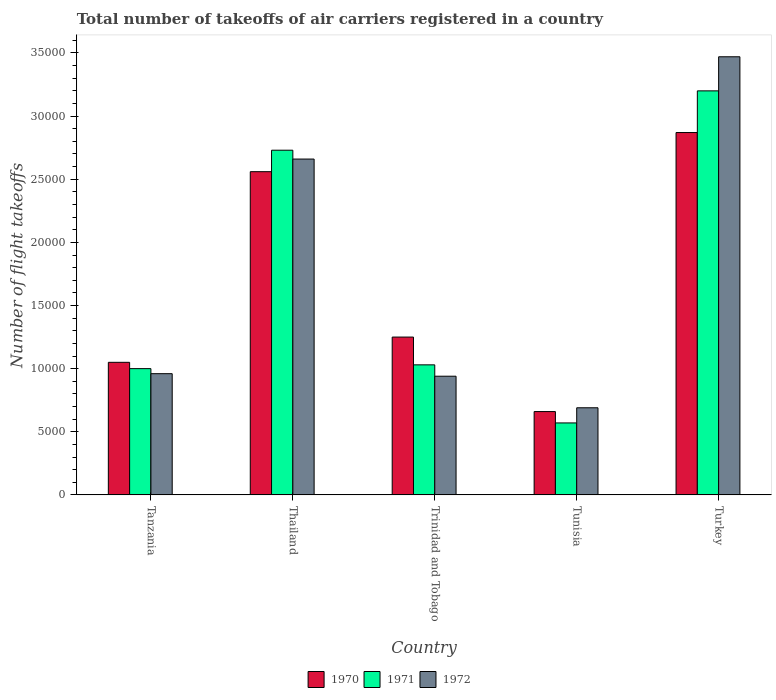How many different coloured bars are there?
Your answer should be very brief. 3. How many groups of bars are there?
Offer a terse response. 5. Are the number of bars per tick equal to the number of legend labels?
Your answer should be compact. Yes. Are the number of bars on each tick of the X-axis equal?
Provide a succinct answer. Yes. How many bars are there on the 2nd tick from the left?
Ensure brevity in your answer.  3. How many bars are there on the 2nd tick from the right?
Offer a very short reply. 3. What is the label of the 5th group of bars from the left?
Give a very brief answer. Turkey. In how many cases, is the number of bars for a given country not equal to the number of legend labels?
Your answer should be compact. 0. What is the total number of flight takeoffs in 1970 in Tunisia?
Give a very brief answer. 6600. Across all countries, what is the maximum total number of flight takeoffs in 1972?
Provide a succinct answer. 3.47e+04. Across all countries, what is the minimum total number of flight takeoffs in 1971?
Offer a terse response. 5700. In which country was the total number of flight takeoffs in 1970 minimum?
Offer a terse response. Tunisia. What is the total total number of flight takeoffs in 1972 in the graph?
Your answer should be very brief. 8.72e+04. What is the difference between the total number of flight takeoffs in 1970 in Trinidad and Tobago and that in Tunisia?
Provide a succinct answer. 5900. What is the difference between the total number of flight takeoffs in 1972 in Tanzania and the total number of flight takeoffs in 1970 in Tunisia?
Your answer should be very brief. 3000. What is the average total number of flight takeoffs in 1972 per country?
Offer a terse response. 1.74e+04. What is the difference between the total number of flight takeoffs of/in 1972 and total number of flight takeoffs of/in 1970 in Trinidad and Tobago?
Your response must be concise. -3100. What is the ratio of the total number of flight takeoffs in 1972 in Thailand to that in Turkey?
Provide a succinct answer. 0.77. What is the difference between the highest and the second highest total number of flight takeoffs in 1971?
Provide a succinct answer. 4700. What is the difference between the highest and the lowest total number of flight takeoffs in 1971?
Ensure brevity in your answer.  2.63e+04. What does the 3rd bar from the right in Turkey represents?
Make the answer very short. 1970. Is it the case that in every country, the sum of the total number of flight takeoffs in 1971 and total number of flight takeoffs in 1972 is greater than the total number of flight takeoffs in 1970?
Your response must be concise. Yes. Are all the bars in the graph horizontal?
Ensure brevity in your answer.  No. What is the difference between two consecutive major ticks on the Y-axis?
Offer a terse response. 5000. Where does the legend appear in the graph?
Give a very brief answer. Bottom center. What is the title of the graph?
Keep it short and to the point. Total number of takeoffs of air carriers registered in a country. What is the label or title of the X-axis?
Give a very brief answer. Country. What is the label or title of the Y-axis?
Ensure brevity in your answer.  Number of flight takeoffs. What is the Number of flight takeoffs in 1970 in Tanzania?
Your response must be concise. 1.05e+04. What is the Number of flight takeoffs in 1971 in Tanzania?
Ensure brevity in your answer.  10000. What is the Number of flight takeoffs in 1972 in Tanzania?
Make the answer very short. 9600. What is the Number of flight takeoffs of 1970 in Thailand?
Offer a very short reply. 2.56e+04. What is the Number of flight takeoffs in 1971 in Thailand?
Your response must be concise. 2.73e+04. What is the Number of flight takeoffs in 1972 in Thailand?
Ensure brevity in your answer.  2.66e+04. What is the Number of flight takeoffs in 1970 in Trinidad and Tobago?
Provide a short and direct response. 1.25e+04. What is the Number of flight takeoffs of 1971 in Trinidad and Tobago?
Provide a short and direct response. 1.03e+04. What is the Number of flight takeoffs in 1972 in Trinidad and Tobago?
Provide a succinct answer. 9400. What is the Number of flight takeoffs in 1970 in Tunisia?
Provide a succinct answer. 6600. What is the Number of flight takeoffs in 1971 in Tunisia?
Give a very brief answer. 5700. What is the Number of flight takeoffs in 1972 in Tunisia?
Offer a terse response. 6900. What is the Number of flight takeoffs in 1970 in Turkey?
Provide a succinct answer. 2.87e+04. What is the Number of flight takeoffs of 1971 in Turkey?
Provide a short and direct response. 3.20e+04. What is the Number of flight takeoffs of 1972 in Turkey?
Offer a terse response. 3.47e+04. Across all countries, what is the maximum Number of flight takeoffs in 1970?
Keep it short and to the point. 2.87e+04. Across all countries, what is the maximum Number of flight takeoffs of 1971?
Keep it short and to the point. 3.20e+04. Across all countries, what is the maximum Number of flight takeoffs in 1972?
Make the answer very short. 3.47e+04. Across all countries, what is the minimum Number of flight takeoffs of 1970?
Keep it short and to the point. 6600. Across all countries, what is the minimum Number of flight takeoffs of 1971?
Your answer should be compact. 5700. Across all countries, what is the minimum Number of flight takeoffs of 1972?
Your response must be concise. 6900. What is the total Number of flight takeoffs in 1970 in the graph?
Give a very brief answer. 8.39e+04. What is the total Number of flight takeoffs in 1971 in the graph?
Offer a terse response. 8.53e+04. What is the total Number of flight takeoffs in 1972 in the graph?
Provide a short and direct response. 8.72e+04. What is the difference between the Number of flight takeoffs in 1970 in Tanzania and that in Thailand?
Make the answer very short. -1.51e+04. What is the difference between the Number of flight takeoffs in 1971 in Tanzania and that in Thailand?
Ensure brevity in your answer.  -1.73e+04. What is the difference between the Number of flight takeoffs of 1972 in Tanzania and that in Thailand?
Provide a succinct answer. -1.70e+04. What is the difference between the Number of flight takeoffs in 1970 in Tanzania and that in Trinidad and Tobago?
Offer a terse response. -2000. What is the difference between the Number of flight takeoffs of 1971 in Tanzania and that in Trinidad and Tobago?
Your response must be concise. -300. What is the difference between the Number of flight takeoffs in 1970 in Tanzania and that in Tunisia?
Your answer should be very brief. 3900. What is the difference between the Number of flight takeoffs in 1971 in Tanzania and that in Tunisia?
Offer a very short reply. 4300. What is the difference between the Number of flight takeoffs in 1972 in Tanzania and that in Tunisia?
Provide a succinct answer. 2700. What is the difference between the Number of flight takeoffs in 1970 in Tanzania and that in Turkey?
Give a very brief answer. -1.82e+04. What is the difference between the Number of flight takeoffs in 1971 in Tanzania and that in Turkey?
Provide a short and direct response. -2.20e+04. What is the difference between the Number of flight takeoffs in 1972 in Tanzania and that in Turkey?
Make the answer very short. -2.51e+04. What is the difference between the Number of flight takeoffs of 1970 in Thailand and that in Trinidad and Tobago?
Your response must be concise. 1.31e+04. What is the difference between the Number of flight takeoffs in 1971 in Thailand and that in Trinidad and Tobago?
Offer a very short reply. 1.70e+04. What is the difference between the Number of flight takeoffs of 1972 in Thailand and that in Trinidad and Tobago?
Provide a succinct answer. 1.72e+04. What is the difference between the Number of flight takeoffs in 1970 in Thailand and that in Tunisia?
Ensure brevity in your answer.  1.90e+04. What is the difference between the Number of flight takeoffs of 1971 in Thailand and that in Tunisia?
Offer a terse response. 2.16e+04. What is the difference between the Number of flight takeoffs of 1972 in Thailand and that in Tunisia?
Provide a succinct answer. 1.97e+04. What is the difference between the Number of flight takeoffs of 1970 in Thailand and that in Turkey?
Provide a short and direct response. -3100. What is the difference between the Number of flight takeoffs in 1971 in Thailand and that in Turkey?
Provide a succinct answer. -4700. What is the difference between the Number of flight takeoffs of 1972 in Thailand and that in Turkey?
Offer a terse response. -8100. What is the difference between the Number of flight takeoffs in 1970 in Trinidad and Tobago and that in Tunisia?
Offer a very short reply. 5900. What is the difference between the Number of flight takeoffs in 1971 in Trinidad and Tobago and that in Tunisia?
Provide a short and direct response. 4600. What is the difference between the Number of flight takeoffs in 1972 in Trinidad and Tobago and that in Tunisia?
Offer a very short reply. 2500. What is the difference between the Number of flight takeoffs in 1970 in Trinidad and Tobago and that in Turkey?
Offer a very short reply. -1.62e+04. What is the difference between the Number of flight takeoffs in 1971 in Trinidad and Tobago and that in Turkey?
Provide a succinct answer. -2.17e+04. What is the difference between the Number of flight takeoffs of 1972 in Trinidad and Tobago and that in Turkey?
Offer a very short reply. -2.53e+04. What is the difference between the Number of flight takeoffs in 1970 in Tunisia and that in Turkey?
Give a very brief answer. -2.21e+04. What is the difference between the Number of flight takeoffs in 1971 in Tunisia and that in Turkey?
Offer a very short reply. -2.63e+04. What is the difference between the Number of flight takeoffs of 1972 in Tunisia and that in Turkey?
Make the answer very short. -2.78e+04. What is the difference between the Number of flight takeoffs of 1970 in Tanzania and the Number of flight takeoffs of 1971 in Thailand?
Give a very brief answer. -1.68e+04. What is the difference between the Number of flight takeoffs of 1970 in Tanzania and the Number of flight takeoffs of 1972 in Thailand?
Ensure brevity in your answer.  -1.61e+04. What is the difference between the Number of flight takeoffs of 1971 in Tanzania and the Number of flight takeoffs of 1972 in Thailand?
Provide a short and direct response. -1.66e+04. What is the difference between the Number of flight takeoffs of 1970 in Tanzania and the Number of flight takeoffs of 1972 in Trinidad and Tobago?
Ensure brevity in your answer.  1100. What is the difference between the Number of flight takeoffs of 1971 in Tanzania and the Number of flight takeoffs of 1972 in Trinidad and Tobago?
Offer a terse response. 600. What is the difference between the Number of flight takeoffs in 1970 in Tanzania and the Number of flight takeoffs in 1971 in Tunisia?
Offer a terse response. 4800. What is the difference between the Number of flight takeoffs in 1970 in Tanzania and the Number of flight takeoffs in 1972 in Tunisia?
Offer a very short reply. 3600. What is the difference between the Number of flight takeoffs of 1971 in Tanzania and the Number of flight takeoffs of 1972 in Tunisia?
Ensure brevity in your answer.  3100. What is the difference between the Number of flight takeoffs of 1970 in Tanzania and the Number of flight takeoffs of 1971 in Turkey?
Keep it short and to the point. -2.15e+04. What is the difference between the Number of flight takeoffs of 1970 in Tanzania and the Number of flight takeoffs of 1972 in Turkey?
Your answer should be compact. -2.42e+04. What is the difference between the Number of flight takeoffs in 1971 in Tanzania and the Number of flight takeoffs in 1972 in Turkey?
Offer a very short reply. -2.47e+04. What is the difference between the Number of flight takeoffs in 1970 in Thailand and the Number of flight takeoffs in 1971 in Trinidad and Tobago?
Make the answer very short. 1.53e+04. What is the difference between the Number of flight takeoffs of 1970 in Thailand and the Number of flight takeoffs of 1972 in Trinidad and Tobago?
Give a very brief answer. 1.62e+04. What is the difference between the Number of flight takeoffs of 1971 in Thailand and the Number of flight takeoffs of 1972 in Trinidad and Tobago?
Make the answer very short. 1.79e+04. What is the difference between the Number of flight takeoffs of 1970 in Thailand and the Number of flight takeoffs of 1971 in Tunisia?
Keep it short and to the point. 1.99e+04. What is the difference between the Number of flight takeoffs of 1970 in Thailand and the Number of flight takeoffs of 1972 in Tunisia?
Your response must be concise. 1.87e+04. What is the difference between the Number of flight takeoffs of 1971 in Thailand and the Number of flight takeoffs of 1972 in Tunisia?
Offer a terse response. 2.04e+04. What is the difference between the Number of flight takeoffs in 1970 in Thailand and the Number of flight takeoffs in 1971 in Turkey?
Provide a short and direct response. -6400. What is the difference between the Number of flight takeoffs in 1970 in Thailand and the Number of flight takeoffs in 1972 in Turkey?
Your response must be concise. -9100. What is the difference between the Number of flight takeoffs in 1971 in Thailand and the Number of flight takeoffs in 1972 in Turkey?
Your answer should be compact. -7400. What is the difference between the Number of flight takeoffs of 1970 in Trinidad and Tobago and the Number of flight takeoffs of 1971 in Tunisia?
Make the answer very short. 6800. What is the difference between the Number of flight takeoffs of 1970 in Trinidad and Tobago and the Number of flight takeoffs of 1972 in Tunisia?
Give a very brief answer. 5600. What is the difference between the Number of flight takeoffs of 1971 in Trinidad and Tobago and the Number of flight takeoffs of 1972 in Tunisia?
Make the answer very short. 3400. What is the difference between the Number of flight takeoffs of 1970 in Trinidad and Tobago and the Number of flight takeoffs of 1971 in Turkey?
Give a very brief answer. -1.95e+04. What is the difference between the Number of flight takeoffs in 1970 in Trinidad and Tobago and the Number of flight takeoffs in 1972 in Turkey?
Your response must be concise. -2.22e+04. What is the difference between the Number of flight takeoffs in 1971 in Trinidad and Tobago and the Number of flight takeoffs in 1972 in Turkey?
Your response must be concise. -2.44e+04. What is the difference between the Number of flight takeoffs of 1970 in Tunisia and the Number of flight takeoffs of 1971 in Turkey?
Ensure brevity in your answer.  -2.54e+04. What is the difference between the Number of flight takeoffs in 1970 in Tunisia and the Number of flight takeoffs in 1972 in Turkey?
Ensure brevity in your answer.  -2.81e+04. What is the difference between the Number of flight takeoffs in 1971 in Tunisia and the Number of flight takeoffs in 1972 in Turkey?
Your response must be concise. -2.90e+04. What is the average Number of flight takeoffs of 1970 per country?
Offer a terse response. 1.68e+04. What is the average Number of flight takeoffs of 1971 per country?
Make the answer very short. 1.71e+04. What is the average Number of flight takeoffs in 1972 per country?
Your answer should be compact. 1.74e+04. What is the difference between the Number of flight takeoffs of 1970 and Number of flight takeoffs of 1972 in Tanzania?
Offer a very short reply. 900. What is the difference between the Number of flight takeoffs of 1970 and Number of flight takeoffs of 1971 in Thailand?
Provide a short and direct response. -1700. What is the difference between the Number of flight takeoffs of 1970 and Number of flight takeoffs of 1972 in Thailand?
Your answer should be compact. -1000. What is the difference between the Number of flight takeoffs in 1971 and Number of flight takeoffs in 1972 in Thailand?
Keep it short and to the point. 700. What is the difference between the Number of flight takeoffs in 1970 and Number of flight takeoffs in 1971 in Trinidad and Tobago?
Your answer should be very brief. 2200. What is the difference between the Number of flight takeoffs of 1970 and Number of flight takeoffs of 1972 in Trinidad and Tobago?
Give a very brief answer. 3100. What is the difference between the Number of flight takeoffs of 1971 and Number of flight takeoffs of 1972 in Trinidad and Tobago?
Ensure brevity in your answer.  900. What is the difference between the Number of flight takeoffs in 1970 and Number of flight takeoffs in 1971 in Tunisia?
Offer a terse response. 900. What is the difference between the Number of flight takeoffs of 1970 and Number of flight takeoffs of 1972 in Tunisia?
Your response must be concise. -300. What is the difference between the Number of flight takeoffs of 1971 and Number of flight takeoffs of 1972 in Tunisia?
Offer a very short reply. -1200. What is the difference between the Number of flight takeoffs of 1970 and Number of flight takeoffs of 1971 in Turkey?
Your answer should be very brief. -3300. What is the difference between the Number of flight takeoffs of 1970 and Number of flight takeoffs of 1972 in Turkey?
Keep it short and to the point. -6000. What is the difference between the Number of flight takeoffs in 1971 and Number of flight takeoffs in 1972 in Turkey?
Offer a very short reply. -2700. What is the ratio of the Number of flight takeoffs in 1970 in Tanzania to that in Thailand?
Offer a very short reply. 0.41. What is the ratio of the Number of flight takeoffs of 1971 in Tanzania to that in Thailand?
Make the answer very short. 0.37. What is the ratio of the Number of flight takeoffs of 1972 in Tanzania to that in Thailand?
Keep it short and to the point. 0.36. What is the ratio of the Number of flight takeoffs in 1970 in Tanzania to that in Trinidad and Tobago?
Provide a short and direct response. 0.84. What is the ratio of the Number of flight takeoffs in 1971 in Tanzania to that in Trinidad and Tobago?
Offer a terse response. 0.97. What is the ratio of the Number of flight takeoffs of 1972 in Tanzania to that in Trinidad and Tobago?
Provide a short and direct response. 1.02. What is the ratio of the Number of flight takeoffs in 1970 in Tanzania to that in Tunisia?
Make the answer very short. 1.59. What is the ratio of the Number of flight takeoffs of 1971 in Tanzania to that in Tunisia?
Your answer should be compact. 1.75. What is the ratio of the Number of flight takeoffs of 1972 in Tanzania to that in Tunisia?
Offer a very short reply. 1.39. What is the ratio of the Number of flight takeoffs of 1970 in Tanzania to that in Turkey?
Offer a very short reply. 0.37. What is the ratio of the Number of flight takeoffs in 1971 in Tanzania to that in Turkey?
Make the answer very short. 0.31. What is the ratio of the Number of flight takeoffs of 1972 in Tanzania to that in Turkey?
Your answer should be compact. 0.28. What is the ratio of the Number of flight takeoffs in 1970 in Thailand to that in Trinidad and Tobago?
Your answer should be compact. 2.05. What is the ratio of the Number of flight takeoffs of 1971 in Thailand to that in Trinidad and Tobago?
Provide a short and direct response. 2.65. What is the ratio of the Number of flight takeoffs of 1972 in Thailand to that in Trinidad and Tobago?
Your response must be concise. 2.83. What is the ratio of the Number of flight takeoffs in 1970 in Thailand to that in Tunisia?
Give a very brief answer. 3.88. What is the ratio of the Number of flight takeoffs of 1971 in Thailand to that in Tunisia?
Keep it short and to the point. 4.79. What is the ratio of the Number of flight takeoffs of 1972 in Thailand to that in Tunisia?
Give a very brief answer. 3.86. What is the ratio of the Number of flight takeoffs in 1970 in Thailand to that in Turkey?
Your answer should be compact. 0.89. What is the ratio of the Number of flight takeoffs in 1971 in Thailand to that in Turkey?
Provide a succinct answer. 0.85. What is the ratio of the Number of flight takeoffs in 1972 in Thailand to that in Turkey?
Your response must be concise. 0.77. What is the ratio of the Number of flight takeoffs in 1970 in Trinidad and Tobago to that in Tunisia?
Make the answer very short. 1.89. What is the ratio of the Number of flight takeoffs in 1971 in Trinidad and Tobago to that in Tunisia?
Keep it short and to the point. 1.81. What is the ratio of the Number of flight takeoffs of 1972 in Trinidad and Tobago to that in Tunisia?
Provide a succinct answer. 1.36. What is the ratio of the Number of flight takeoffs in 1970 in Trinidad and Tobago to that in Turkey?
Provide a succinct answer. 0.44. What is the ratio of the Number of flight takeoffs of 1971 in Trinidad and Tobago to that in Turkey?
Make the answer very short. 0.32. What is the ratio of the Number of flight takeoffs of 1972 in Trinidad and Tobago to that in Turkey?
Offer a very short reply. 0.27. What is the ratio of the Number of flight takeoffs of 1970 in Tunisia to that in Turkey?
Make the answer very short. 0.23. What is the ratio of the Number of flight takeoffs in 1971 in Tunisia to that in Turkey?
Keep it short and to the point. 0.18. What is the ratio of the Number of flight takeoffs of 1972 in Tunisia to that in Turkey?
Make the answer very short. 0.2. What is the difference between the highest and the second highest Number of flight takeoffs in 1970?
Give a very brief answer. 3100. What is the difference between the highest and the second highest Number of flight takeoffs in 1971?
Your answer should be very brief. 4700. What is the difference between the highest and the second highest Number of flight takeoffs of 1972?
Keep it short and to the point. 8100. What is the difference between the highest and the lowest Number of flight takeoffs of 1970?
Offer a terse response. 2.21e+04. What is the difference between the highest and the lowest Number of flight takeoffs of 1971?
Provide a short and direct response. 2.63e+04. What is the difference between the highest and the lowest Number of flight takeoffs in 1972?
Your response must be concise. 2.78e+04. 